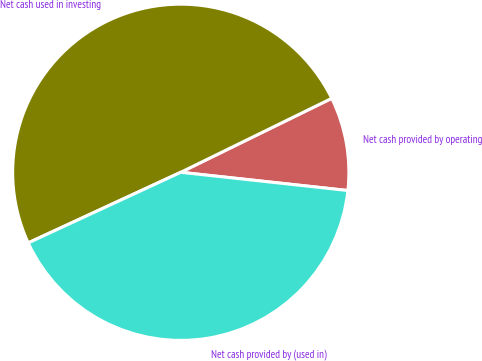<chart> <loc_0><loc_0><loc_500><loc_500><pie_chart><fcel>Net cash provided by operating<fcel>Net cash used in investing<fcel>Net cash provided by (used in)<nl><fcel>8.98%<fcel>49.65%<fcel>41.37%<nl></chart> 